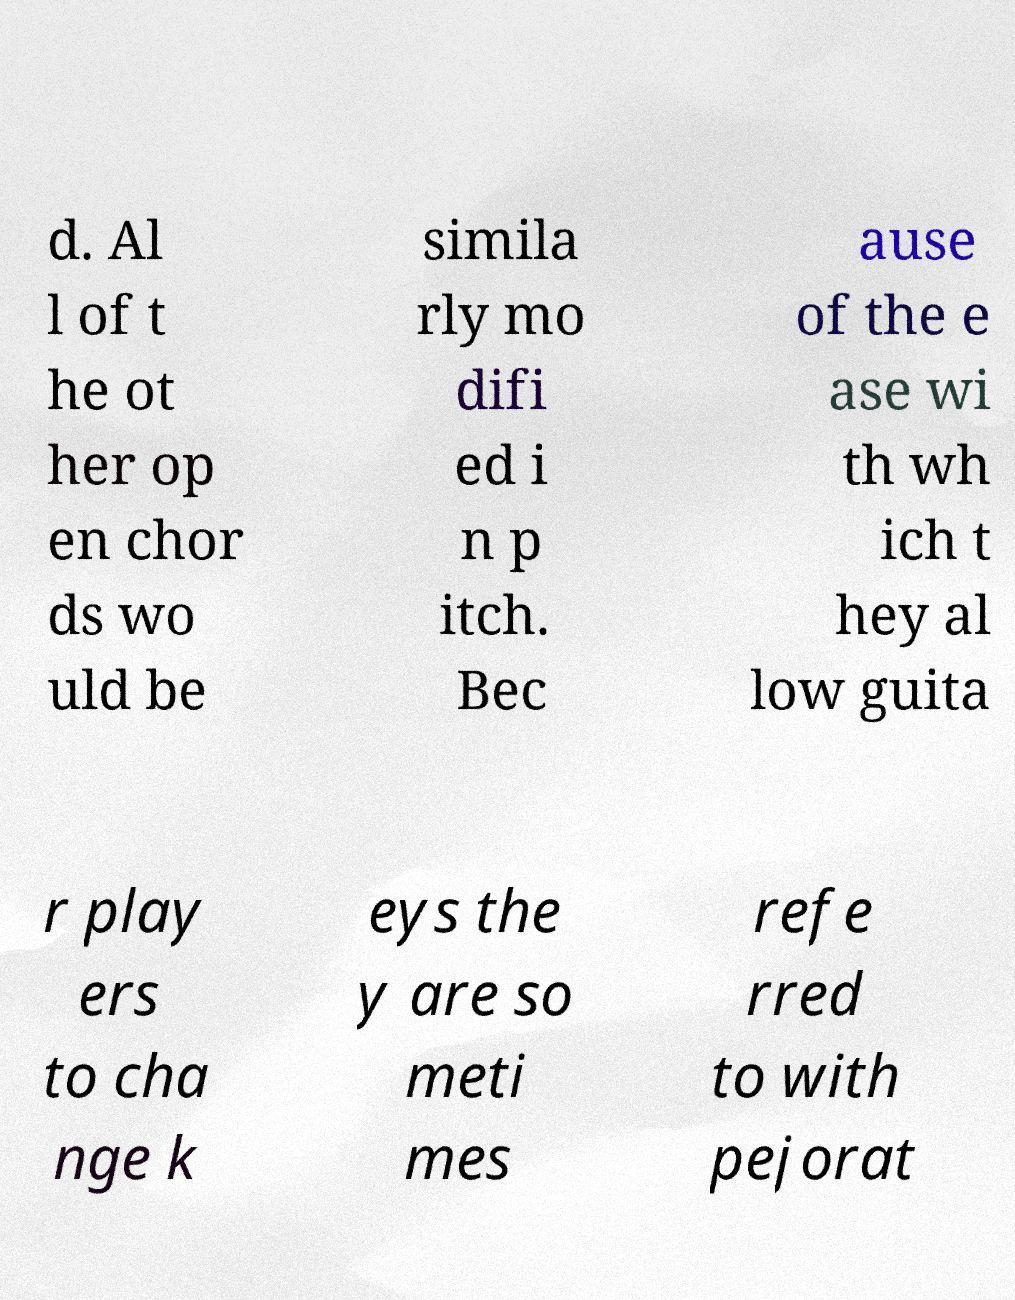For documentation purposes, I need the text within this image transcribed. Could you provide that? d. Al l of t he ot her op en chor ds wo uld be simila rly mo difi ed i n p itch. Bec ause of the e ase wi th wh ich t hey al low guita r play ers to cha nge k eys the y are so meti mes refe rred to with pejorat 